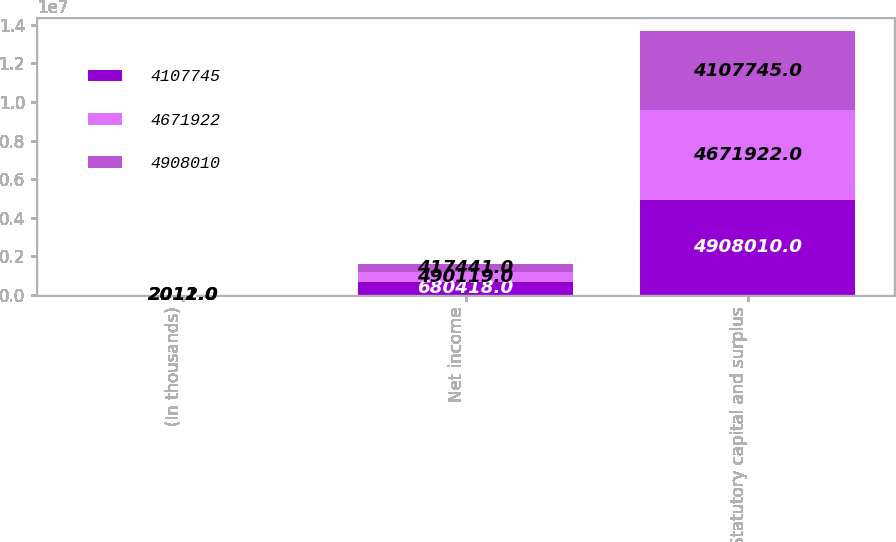<chart> <loc_0><loc_0><loc_500><loc_500><stacked_bar_chart><ecel><fcel>(In thousands)<fcel>Net income<fcel>Statutory capital and surplus<nl><fcel>4.10774e+06<fcel>2013<fcel>680418<fcel>4.90801e+06<nl><fcel>4.67192e+06<fcel>2012<fcel>490119<fcel>4.67192e+06<nl><fcel>4.90801e+06<fcel>2011<fcel>417441<fcel>4.10774e+06<nl></chart> 